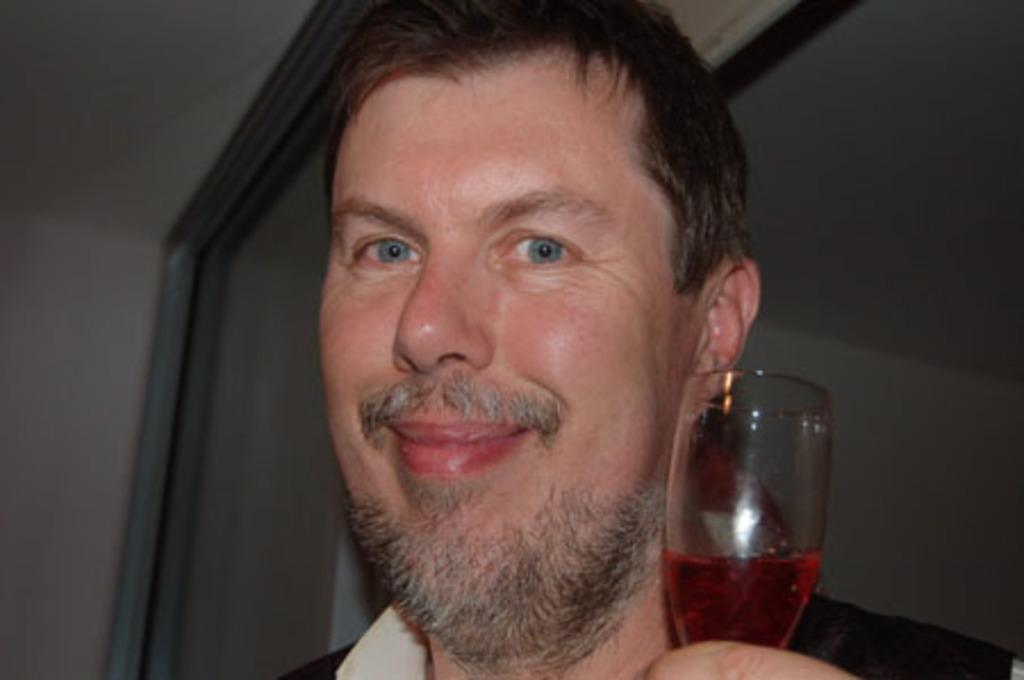Who is present in the image? There is a person in the image. What is the person holding in the image? The person is holding a glass. What is inside the glass? The glass contains some liquid. What can be seen in the background of the image? There is a wall in the background of the image. Are there any other glass objects visible in the image? Yes, there are other glass objects visible in the image. What type of fight is taking place between the achiever and the blade in the image? There is no achiever or blade present in the image, and therefore no such fight can be observed. 